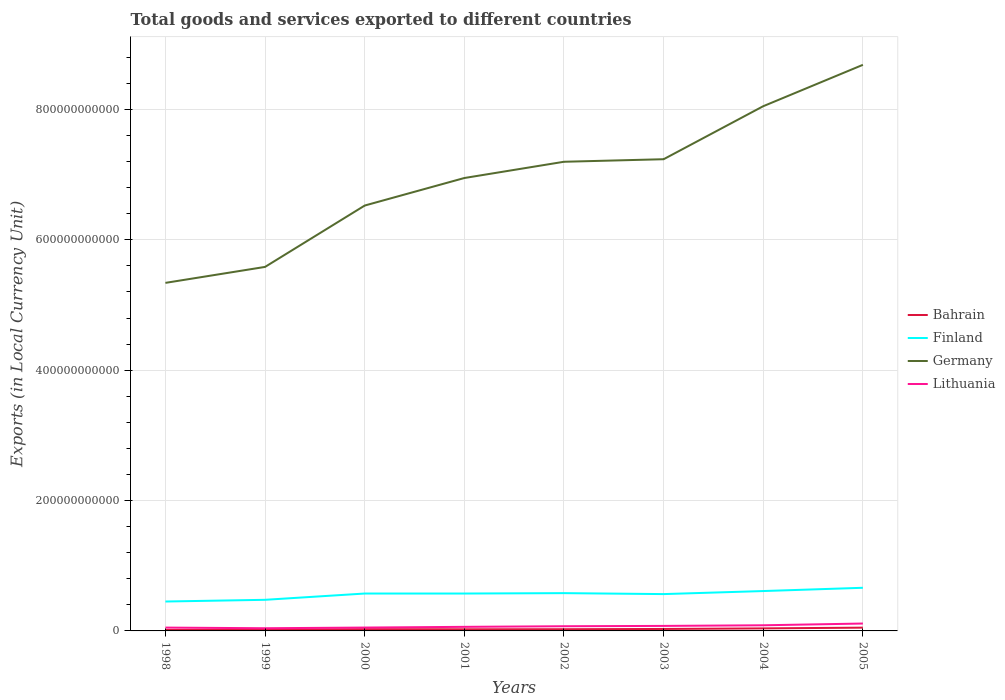How many different coloured lines are there?
Provide a succinct answer. 4. Does the line corresponding to Lithuania intersect with the line corresponding to Finland?
Give a very brief answer. No. Across all years, what is the maximum Amount of goods and services exports in Finland?
Ensure brevity in your answer.  4.51e+1. In which year was the Amount of goods and services exports in Lithuania maximum?
Offer a very short reply. 1999. What is the total Amount of goods and services exports in Finland in the graph?
Keep it short and to the point. -6.12e+08. What is the difference between the highest and the second highest Amount of goods and services exports in Lithuania?
Keep it short and to the point. 7.20e+09. How many years are there in the graph?
Keep it short and to the point. 8. What is the difference between two consecutive major ticks on the Y-axis?
Offer a terse response. 2.00e+11. Does the graph contain any zero values?
Make the answer very short. No. Does the graph contain grids?
Your answer should be compact. Yes. Where does the legend appear in the graph?
Provide a short and direct response. Center right. How many legend labels are there?
Your answer should be compact. 4. How are the legend labels stacked?
Offer a terse response. Vertical. What is the title of the graph?
Offer a terse response. Total goods and services exported to different countries. Does "Switzerland" appear as one of the legend labels in the graph?
Provide a succinct answer. No. What is the label or title of the X-axis?
Provide a succinct answer. Years. What is the label or title of the Y-axis?
Provide a succinct answer. Exports (in Local Currency Unit). What is the Exports (in Local Currency Unit) of Bahrain in 1998?
Give a very brief answer. 1.50e+09. What is the Exports (in Local Currency Unit) in Finland in 1998?
Offer a very short reply. 4.51e+1. What is the Exports (in Local Currency Unit) of Germany in 1998?
Provide a short and direct response. 5.34e+11. What is the Exports (in Local Currency Unit) in Lithuania in 1998?
Offer a very short reply. 5.09e+09. What is the Exports (in Local Currency Unit) in Bahrain in 1999?
Provide a short and direct response. 1.96e+09. What is the Exports (in Local Currency Unit) in Finland in 1999?
Offer a very short reply. 4.77e+1. What is the Exports (in Local Currency Unit) of Germany in 1999?
Provide a succinct answer. 5.58e+11. What is the Exports (in Local Currency Unit) in Lithuania in 1999?
Your answer should be compact. 4.12e+09. What is the Exports (in Local Currency Unit) in Bahrain in 2000?
Your response must be concise. 2.70e+09. What is the Exports (in Local Currency Unit) in Finland in 2000?
Your answer should be very brief. 5.73e+1. What is the Exports (in Local Currency Unit) of Germany in 2000?
Your answer should be very brief. 6.53e+11. What is the Exports (in Local Currency Unit) in Lithuania in 2000?
Your answer should be very brief. 5.15e+09. What is the Exports (in Local Currency Unit) in Bahrain in 2001?
Give a very brief answer. 2.48e+09. What is the Exports (in Local Currency Unit) of Finland in 2001?
Provide a succinct answer. 5.74e+1. What is the Exports (in Local Currency Unit) of Germany in 2001?
Provide a short and direct response. 6.95e+11. What is the Exports (in Local Currency Unit) of Lithuania in 2001?
Offer a terse response. 6.25e+09. What is the Exports (in Local Currency Unit) of Bahrain in 2002?
Keep it short and to the point. 2.62e+09. What is the Exports (in Local Currency Unit) of Finland in 2002?
Offer a terse response. 5.80e+1. What is the Exports (in Local Currency Unit) in Germany in 2002?
Offer a very short reply. 7.20e+11. What is the Exports (in Local Currency Unit) in Lithuania in 2002?
Your response must be concise. 7.20e+09. What is the Exports (in Local Currency Unit) in Bahrain in 2003?
Give a very brief answer. 3.00e+09. What is the Exports (in Local Currency Unit) of Finland in 2003?
Keep it short and to the point. 5.65e+1. What is the Exports (in Local Currency Unit) of Germany in 2003?
Offer a very short reply. 7.24e+11. What is the Exports (in Local Currency Unit) in Lithuania in 2003?
Your response must be concise. 7.70e+09. What is the Exports (in Local Currency Unit) in Bahrain in 2004?
Provide a succinct answer. 3.89e+09. What is the Exports (in Local Currency Unit) of Finland in 2004?
Your answer should be compact. 6.12e+1. What is the Exports (in Local Currency Unit) in Germany in 2004?
Offer a very short reply. 8.05e+11. What is the Exports (in Local Currency Unit) of Lithuania in 2004?
Your response must be concise. 8.64e+09. What is the Exports (in Local Currency Unit) of Bahrain in 2005?
Make the answer very short. 5.04e+09. What is the Exports (in Local Currency Unit) of Finland in 2005?
Offer a terse response. 6.62e+1. What is the Exports (in Local Currency Unit) in Germany in 2005?
Your answer should be very brief. 8.68e+11. What is the Exports (in Local Currency Unit) in Lithuania in 2005?
Provide a short and direct response. 1.13e+1. Across all years, what is the maximum Exports (in Local Currency Unit) of Bahrain?
Your response must be concise. 5.04e+09. Across all years, what is the maximum Exports (in Local Currency Unit) in Finland?
Provide a succinct answer. 6.62e+1. Across all years, what is the maximum Exports (in Local Currency Unit) in Germany?
Make the answer very short. 8.68e+11. Across all years, what is the maximum Exports (in Local Currency Unit) of Lithuania?
Make the answer very short. 1.13e+1. Across all years, what is the minimum Exports (in Local Currency Unit) in Bahrain?
Your response must be concise. 1.50e+09. Across all years, what is the minimum Exports (in Local Currency Unit) in Finland?
Provide a short and direct response. 4.51e+1. Across all years, what is the minimum Exports (in Local Currency Unit) in Germany?
Offer a terse response. 5.34e+11. Across all years, what is the minimum Exports (in Local Currency Unit) of Lithuania?
Your answer should be very brief. 4.12e+09. What is the total Exports (in Local Currency Unit) in Bahrain in the graph?
Your answer should be compact. 2.32e+1. What is the total Exports (in Local Currency Unit) in Finland in the graph?
Make the answer very short. 4.49e+11. What is the total Exports (in Local Currency Unit) in Germany in the graph?
Your answer should be compact. 5.56e+12. What is the total Exports (in Local Currency Unit) in Lithuania in the graph?
Your answer should be compact. 5.55e+1. What is the difference between the Exports (in Local Currency Unit) of Bahrain in 1998 and that in 1999?
Offer a very short reply. -4.61e+08. What is the difference between the Exports (in Local Currency Unit) in Finland in 1998 and that in 1999?
Provide a succinct answer. -2.62e+09. What is the difference between the Exports (in Local Currency Unit) in Germany in 1998 and that in 1999?
Your answer should be compact. -2.45e+1. What is the difference between the Exports (in Local Currency Unit) in Lithuania in 1998 and that in 1999?
Ensure brevity in your answer.  9.74e+08. What is the difference between the Exports (in Local Currency Unit) in Bahrain in 1998 and that in 2000?
Make the answer very short. -1.20e+09. What is the difference between the Exports (in Local Currency Unit) of Finland in 1998 and that in 2000?
Provide a succinct answer. -1.22e+1. What is the difference between the Exports (in Local Currency Unit) of Germany in 1998 and that in 2000?
Offer a terse response. -1.19e+11. What is the difference between the Exports (in Local Currency Unit) of Lithuania in 1998 and that in 2000?
Offer a terse response. -5.80e+07. What is the difference between the Exports (in Local Currency Unit) in Bahrain in 1998 and that in 2001?
Offer a very short reply. -9.82e+08. What is the difference between the Exports (in Local Currency Unit) in Finland in 1998 and that in 2001?
Make the answer very short. -1.23e+1. What is the difference between the Exports (in Local Currency Unit) of Germany in 1998 and that in 2001?
Provide a succinct answer. -1.61e+11. What is the difference between the Exports (in Local Currency Unit) of Lithuania in 1998 and that in 2001?
Offer a very short reply. -1.16e+09. What is the difference between the Exports (in Local Currency Unit) of Bahrain in 1998 and that in 2002?
Provide a short and direct response. -1.11e+09. What is the difference between the Exports (in Local Currency Unit) in Finland in 1998 and that in 2002?
Provide a short and direct response. -1.29e+1. What is the difference between the Exports (in Local Currency Unit) in Germany in 1998 and that in 2002?
Provide a succinct answer. -1.86e+11. What is the difference between the Exports (in Local Currency Unit) of Lithuania in 1998 and that in 2002?
Make the answer very short. -2.10e+09. What is the difference between the Exports (in Local Currency Unit) of Bahrain in 1998 and that in 2003?
Offer a very short reply. -1.50e+09. What is the difference between the Exports (in Local Currency Unit) in Finland in 1998 and that in 2003?
Your response must be concise. -1.14e+1. What is the difference between the Exports (in Local Currency Unit) in Germany in 1998 and that in 2003?
Ensure brevity in your answer.  -1.90e+11. What is the difference between the Exports (in Local Currency Unit) of Lithuania in 1998 and that in 2003?
Provide a succinct answer. -2.60e+09. What is the difference between the Exports (in Local Currency Unit) in Bahrain in 1998 and that in 2004?
Keep it short and to the point. -2.38e+09. What is the difference between the Exports (in Local Currency Unit) of Finland in 1998 and that in 2004?
Offer a terse response. -1.61e+1. What is the difference between the Exports (in Local Currency Unit) of Germany in 1998 and that in 2004?
Provide a short and direct response. -2.71e+11. What is the difference between the Exports (in Local Currency Unit) of Lithuania in 1998 and that in 2004?
Offer a very short reply. -3.55e+09. What is the difference between the Exports (in Local Currency Unit) in Bahrain in 1998 and that in 2005?
Offer a very short reply. -3.54e+09. What is the difference between the Exports (in Local Currency Unit) in Finland in 1998 and that in 2005?
Your answer should be compact. -2.11e+1. What is the difference between the Exports (in Local Currency Unit) of Germany in 1998 and that in 2005?
Provide a succinct answer. -3.34e+11. What is the difference between the Exports (in Local Currency Unit) in Lithuania in 1998 and that in 2005?
Keep it short and to the point. -6.23e+09. What is the difference between the Exports (in Local Currency Unit) of Bahrain in 1999 and that in 2000?
Offer a very short reply. -7.35e+08. What is the difference between the Exports (in Local Currency Unit) of Finland in 1999 and that in 2000?
Give a very brief answer. -9.62e+09. What is the difference between the Exports (in Local Currency Unit) of Germany in 1999 and that in 2000?
Offer a very short reply. -9.41e+1. What is the difference between the Exports (in Local Currency Unit) of Lithuania in 1999 and that in 2000?
Your answer should be compact. -1.03e+09. What is the difference between the Exports (in Local Currency Unit) of Bahrain in 1999 and that in 2001?
Keep it short and to the point. -5.21e+08. What is the difference between the Exports (in Local Currency Unit) of Finland in 1999 and that in 2001?
Provide a short and direct response. -9.63e+09. What is the difference between the Exports (in Local Currency Unit) of Germany in 1999 and that in 2001?
Your response must be concise. -1.36e+11. What is the difference between the Exports (in Local Currency Unit) of Lithuania in 1999 and that in 2001?
Provide a short and direct response. -2.13e+09. What is the difference between the Exports (in Local Currency Unit) of Bahrain in 1999 and that in 2002?
Your answer should be compact. -6.52e+08. What is the difference between the Exports (in Local Currency Unit) of Finland in 1999 and that in 2002?
Your answer should be compact. -1.02e+1. What is the difference between the Exports (in Local Currency Unit) in Germany in 1999 and that in 2002?
Provide a succinct answer. -1.61e+11. What is the difference between the Exports (in Local Currency Unit) in Lithuania in 1999 and that in 2002?
Your answer should be very brief. -3.08e+09. What is the difference between the Exports (in Local Currency Unit) of Bahrain in 1999 and that in 2003?
Provide a short and direct response. -1.04e+09. What is the difference between the Exports (in Local Currency Unit) in Finland in 1999 and that in 2003?
Give a very brief answer. -8.76e+09. What is the difference between the Exports (in Local Currency Unit) in Germany in 1999 and that in 2003?
Give a very brief answer. -1.65e+11. What is the difference between the Exports (in Local Currency Unit) of Lithuania in 1999 and that in 2003?
Give a very brief answer. -3.58e+09. What is the difference between the Exports (in Local Currency Unit) of Bahrain in 1999 and that in 2004?
Keep it short and to the point. -1.92e+09. What is the difference between the Exports (in Local Currency Unit) in Finland in 1999 and that in 2004?
Keep it short and to the point. -1.34e+1. What is the difference between the Exports (in Local Currency Unit) of Germany in 1999 and that in 2004?
Make the answer very short. -2.47e+11. What is the difference between the Exports (in Local Currency Unit) of Lithuania in 1999 and that in 2004?
Give a very brief answer. -4.52e+09. What is the difference between the Exports (in Local Currency Unit) of Bahrain in 1999 and that in 2005?
Keep it short and to the point. -3.07e+09. What is the difference between the Exports (in Local Currency Unit) in Finland in 1999 and that in 2005?
Offer a terse response. -1.84e+1. What is the difference between the Exports (in Local Currency Unit) of Germany in 1999 and that in 2005?
Provide a succinct answer. -3.10e+11. What is the difference between the Exports (in Local Currency Unit) in Lithuania in 1999 and that in 2005?
Your response must be concise. -7.20e+09. What is the difference between the Exports (in Local Currency Unit) in Bahrain in 2000 and that in 2001?
Offer a very short reply. 2.14e+08. What is the difference between the Exports (in Local Currency Unit) of Finland in 2000 and that in 2001?
Ensure brevity in your answer.  -1.20e+07. What is the difference between the Exports (in Local Currency Unit) of Germany in 2000 and that in 2001?
Offer a very short reply. -4.22e+1. What is the difference between the Exports (in Local Currency Unit) of Lithuania in 2000 and that in 2001?
Provide a short and direct response. -1.10e+09. What is the difference between the Exports (in Local Currency Unit) of Bahrain in 2000 and that in 2002?
Your answer should be very brief. 8.27e+07. What is the difference between the Exports (in Local Currency Unit) in Finland in 2000 and that in 2002?
Your response must be concise. -6.12e+08. What is the difference between the Exports (in Local Currency Unit) of Germany in 2000 and that in 2002?
Make the answer very short. -6.72e+1. What is the difference between the Exports (in Local Currency Unit) in Lithuania in 2000 and that in 2002?
Provide a succinct answer. -2.04e+09. What is the difference between the Exports (in Local Currency Unit) in Bahrain in 2000 and that in 2003?
Your answer should be very brief. -3.03e+08. What is the difference between the Exports (in Local Currency Unit) of Finland in 2000 and that in 2003?
Your answer should be compact. 8.64e+08. What is the difference between the Exports (in Local Currency Unit) of Germany in 2000 and that in 2003?
Provide a succinct answer. -7.11e+1. What is the difference between the Exports (in Local Currency Unit) of Lithuania in 2000 and that in 2003?
Ensure brevity in your answer.  -2.54e+09. What is the difference between the Exports (in Local Currency Unit) in Bahrain in 2000 and that in 2004?
Offer a terse response. -1.19e+09. What is the difference between the Exports (in Local Currency Unit) of Finland in 2000 and that in 2004?
Your answer should be very brief. -3.81e+09. What is the difference between the Exports (in Local Currency Unit) in Germany in 2000 and that in 2004?
Give a very brief answer. -1.52e+11. What is the difference between the Exports (in Local Currency Unit) in Lithuania in 2000 and that in 2004?
Your answer should be very brief. -3.49e+09. What is the difference between the Exports (in Local Currency Unit) of Bahrain in 2000 and that in 2005?
Your answer should be compact. -2.34e+09. What is the difference between the Exports (in Local Currency Unit) in Finland in 2000 and that in 2005?
Offer a terse response. -8.83e+09. What is the difference between the Exports (in Local Currency Unit) of Germany in 2000 and that in 2005?
Ensure brevity in your answer.  -2.16e+11. What is the difference between the Exports (in Local Currency Unit) of Lithuania in 2000 and that in 2005?
Keep it short and to the point. -6.17e+09. What is the difference between the Exports (in Local Currency Unit) of Bahrain in 2001 and that in 2002?
Provide a short and direct response. -1.31e+08. What is the difference between the Exports (in Local Currency Unit) of Finland in 2001 and that in 2002?
Keep it short and to the point. -6.00e+08. What is the difference between the Exports (in Local Currency Unit) in Germany in 2001 and that in 2002?
Give a very brief answer. -2.49e+1. What is the difference between the Exports (in Local Currency Unit) in Lithuania in 2001 and that in 2002?
Offer a very short reply. -9.45e+08. What is the difference between the Exports (in Local Currency Unit) in Bahrain in 2001 and that in 2003?
Make the answer very short. -5.16e+08. What is the difference between the Exports (in Local Currency Unit) of Finland in 2001 and that in 2003?
Give a very brief answer. 8.76e+08. What is the difference between the Exports (in Local Currency Unit) of Germany in 2001 and that in 2003?
Your response must be concise. -2.88e+1. What is the difference between the Exports (in Local Currency Unit) in Lithuania in 2001 and that in 2003?
Offer a very short reply. -1.44e+09. What is the difference between the Exports (in Local Currency Unit) in Bahrain in 2001 and that in 2004?
Your answer should be very brief. -1.40e+09. What is the difference between the Exports (in Local Currency Unit) in Finland in 2001 and that in 2004?
Provide a short and direct response. -3.80e+09. What is the difference between the Exports (in Local Currency Unit) of Germany in 2001 and that in 2004?
Your answer should be compact. -1.10e+11. What is the difference between the Exports (in Local Currency Unit) in Lithuania in 2001 and that in 2004?
Your answer should be compact. -2.39e+09. What is the difference between the Exports (in Local Currency Unit) in Bahrain in 2001 and that in 2005?
Make the answer very short. -2.55e+09. What is the difference between the Exports (in Local Currency Unit) in Finland in 2001 and that in 2005?
Your response must be concise. -8.82e+09. What is the difference between the Exports (in Local Currency Unit) in Germany in 2001 and that in 2005?
Provide a succinct answer. -1.74e+11. What is the difference between the Exports (in Local Currency Unit) in Lithuania in 2001 and that in 2005?
Offer a terse response. -5.07e+09. What is the difference between the Exports (in Local Currency Unit) in Bahrain in 2002 and that in 2003?
Your answer should be compact. -3.85e+08. What is the difference between the Exports (in Local Currency Unit) in Finland in 2002 and that in 2003?
Ensure brevity in your answer.  1.48e+09. What is the difference between the Exports (in Local Currency Unit) of Germany in 2002 and that in 2003?
Offer a terse response. -3.90e+09. What is the difference between the Exports (in Local Currency Unit) of Lithuania in 2002 and that in 2003?
Your answer should be compact. -4.99e+08. What is the difference between the Exports (in Local Currency Unit) in Bahrain in 2002 and that in 2004?
Your response must be concise. -1.27e+09. What is the difference between the Exports (in Local Currency Unit) of Finland in 2002 and that in 2004?
Offer a terse response. -3.20e+09. What is the difference between the Exports (in Local Currency Unit) in Germany in 2002 and that in 2004?
Keep it short and to the point. -8.52e+1. What is the difference between the Exports (in Local Currency Unit) of Lithuania in 2002 and that in 2004?
Keep it short and to the point. -1.45e+09. What is the difference between the Exports (in Local Currency Unit) of Bahrain in 2002 and that in 2005?
Keep it short and to the point. -2.42e+09. What is the difference between the Exports (in Local Currency Unit) in Finland in 2002 and that in 2005?
Your response must be concise. -8.22e+09. What is the difference between the Exports (in Local Currency Unit) of Germany in 2002 and that in 2005?
Provide a succinct answer. -1.49e+11. What is the difference between the Exports (in Local Currency Unit) in Lithuania in 2002 and that in 2005?
Offer a very short reply. -4.13e+09. What is the difference between the Exports (in Local Currency Unit) of Bahrain in 2003 and that in 2004?
Provide a succinct answer. -8.86e+08. What is the difference between the Exports (in Local Currency Unit) in Finland in 2003 and that in 2004?
Ensure brevity in your answer.  -4.67e+09. What is the difference between the Exports (in Local Currency Unit) in Germany in 2003 and that in 2004?
Provide a short and direct response. -8.13e+1. What is the difference between the Exports (in Local Currency Unit) of Lithuania in 2003 and that in 2004?
Ensure brevity in your answer.  -9.48e+08. What is the difference between the Exports (in Local Currency Unit) of Bahrain in 2003 and that in 2005?
Make the answer very short. -2.04e+09. What is the difference between the Exports (in Local Currency Unit) in Finland in 2003 and that in 2005?
Ensure brevity in your answer.  -9.69e+09. What is the difference between the Exports (in Local Currency Unit) of Germany in 2003 and that in 2005?
Give a very brief answer. -1.45e+11. What is the difference between the Exports (in Local Currency Unit) in Lithuania in 2003 and that in 2005?
Offer a very short reply. -3.63e+09. What is the difference between the Exports (in Local Currency Unit) of Bahrain in 2004 and that in 2005?
Make the answer very short. -1.15e+09. What is the difference between the Exports (in Local Currency Unit) in Finland in 2004 and that in 2005?
Your response must be concise. -5.02e+09. What is the difference between the Exports (in Local Currency Unit) in Germany in 2004 and that in 2005?
Provide a short and direct response. -6.35e+1. What is the difference between the Exports (in Local Currency Unit) of Lithuania in 2004 and that in 2005?
Give a very brief answer. -2.68e+09. What is the difference between the Exports (in Local Currency Unit) in Bahrain in 1998 and the Exports (in Local Currency Unit) in Finland in 1999?
Offer a very short reply. -4.62e+1. What is the difference between the Exports (in Local Currency Unit) of Bahrain in 1998 and the Exports (in Local Currency Unit) of Germany in 1999?
Your answer should be very brief. -5.57e+11. What is the difference between the Exports (in Local Currency Unit) in Bahrain in 1998 and the Exports (in Local Currency Unit) in Lithuania in 1999?
Provide a short and direct response. -2.62e+09. What is the difference between the Exports (in Local Currency Unit) in Finland in 1998 and the Exports (in Local Currency Unit) in Germany in 1999?
Your answer should be compact. -5.13e+11. What is the difference between the Exports (in Local Currency Unit) in Finland in 1998 and the Exports (in Local Currency Unit) in Lithuania in 1999?
Make the answer very short. 4.10e+1. What is the difference between the Exports (in Local Currency Unit) in Germany in 1998 and the Exports (in Local Currency Unit) in Lithuania in 1999?
Your response must be concise. 5.30e+11. What is the difference between the Exports (in Local Currency Unit) of Bahrain in 1998 and the Exports (in Local Currency Unit) of Finland in 2000?
Offer a terse response. -5.58e+1. What is the difference between the Exports (in Local Currency Unit) of Bahrain in 1998 and the Exports (in Local Currency Unit) of Germany in 2000?
Give a very brief answer. -6.51e+11. What is the difference between the Exports (in Local Currency Unit) of Bahrain in 1998 and the Exports (in Local Currency Unit) of Lithuania in 2000?
Offer a terse response. -3.65e+09. What is the difference between the Exports (in Local Currency Unit) of Finland in 1998 and the Exports (in Local Currency Unit) of Germany in 2000?
Provide a succinct answer. -6.07e+11. What is the difference between the Exports (in Local Currency Unit) of Finland in 1998 and the Exports (in Local Currency Unit) of Lithuania in 2000?
Ensure brevity in your answer.  4.00e+1. What is the difference between the Exports (in Local Currency Unit) of Germany in 1998 and the Exports (in Local Currency Unit) of Lithuania in 2000?
Provide a succinct answer. 5.29e+11. What is the difference between the Exports (in Local Currency Unit) of Bahrain in 1998 and the Exports (in Local Currency Unit) of Finland in 2001?
Keep it short and to the point. -5.59e+1. What is the difference between the Exports (in Local Currency Unit) of Bahrain in 1998 and the Exports (in Local Currency Unit) of Germany in 2001?
Your answer should be very brief. -6.93e+11. What is the difference between the Exports (in Local Currency Unit) in Bahrain in 1998 and the Exports (in Local Currency Unit) in Lithuania in 2001?
Offer a terse response. -4.75e+09. What is the difference between the Exports (in Local Currency Unit) in Finland in 1998 and the Exports (in Local Currency Unit) in Germany in 2001?
Your answer should be very brief. -6.50e+11. What is the difference between the Exports (in Local Currency Unit) in Finland in 1998 and the Exports (in Local Currency Unit) in Lithuania in 2001?
Your answer should be compact. 3.89e+1. What is the difference between the Exports (in Local Currency Unit) of Germany in 1998 and the Exports (in Local Currency Unit) of Lithuania in 2001?
Offer a very short reply. 5.28e+11. What is the difference between the Exports (in Local Currency Unit) of Bahrain in 1998 and the Exports (in Local Currency Unit) of Finland in 2002?
Give a very brief answer. -5.65e+1. What is the difference between the Exports (in Local Currency Unit) in Bahrain in 1998 and the Exports (in Local Currency Unit) in Germany in 2002?
Ensure brevity in your answer.  -7.18e+11. What is the difference between the Exports (in Local Currency Unit) in Bahrain in 1998 and the Exports (in Local Currency Unit) in Lithuania in 2002?
Provide a short and direct response. -5.69e+09. What is the difference between the Exports (in Local Currency Unit) in Finland in 1998 and the Exports (in Local Currency Unit) in Germany in 2002?
Ensure brevity in your answer.  -6.75e+11. What is the difference between the Exports (in Local Currency Unit) of Finland in 1998 and the Exports (in Local Currency Unit) of Lithuania in 2002?
Your answer should be very brief. 3.79e+1. What is the difference between the Exports (in Local Currency Unit) of Germany in 1998 and the Exports (in Local Currency Unit) of Lithuania in 2002?
Provide a short and direct response. 5.27e+11. What is the difference between the Exports (in Local Currency Unit) of Bahrain in 1998 and the Exports (in Local Currency Unit) of Finland in 2003?
Your answer should be compact. -5.50e+1. What is the difference between the Exports (in Local Currency Unit) in Bahrain in 1998 and the Exports (in Local Currency Unit) in Germany in 2003?
Offer a terse response. -7.22e+11. What is the difference between the Exports (in Local Currency Unit) in Bahrain in 1998 and the Exports (in Local Currency Unit) in Lithuania in 2003?
Make the answer very short. -6.19e+09. What is the difference between the Exports (in Local Currency Unit) in Finland in 1998 and the Exports (in Local Currency Unit) in Germany in 2003?
Your answer should be compact. -6.78e+11. What is the difference between the Exports (in Local Currency Unit) of Finland in 1998 and the Exports (in Local Currency Unit) of Lithuania in 2003?
Provide a short and direct response. 3.74e+1. What is the difference between the Exports (in Local Currency Unit) in Germany in 1998 and the Exports (in Local Currency Unit) in Lithuania in 2003?
Make the answer very short. 5.26e+11. What is the difference between the Exports (in Local Currency Unit) of Bahrain in 1998 and the Exports (in Local Currency Unit) of Finland in 2004?
Give a very brief answer. -5.97e+1. What is the difference between the Exports (in Local Currency Unit) in Bahrain in 1998 and the Exports (in Local Currency Unit) in Germany in 2004?
Keep it short and to the point. -8.03e+11. What is the difference between the Exports (in Local Currency Unit) in Bahrain in 1998 and the Exports (in Local Currency Unit) in Lithuania in 2004?
Give a very brief answer. -7.14e+09. What is the difference between the Exports (in Local Currency Unit) in Finland in 1998 and the Exports (in Local Currency Unit) in Germany in 2004?
Your answer should be very brief. -7.60e+11. What is the difference between the Exports (in Local Currency Unit) of Finland in 1998 and the Exports (in Local Currency Unit) of Lithuania in 2004?
Keep it short and to the point. 3.65e+1. What is the difference between the Exports (in Local Currency Unit) in Germany in 1998 and the Exports (in Local Currency Unit) in Lithuania in 2004?
Offer a very short reply. 5.25e+11. What is the difference between the Exports (in Local Currency Unit) of Bahrain in 1998 and the Exports (in Local Currency Unit) of Finland in 2005?
Keep it short and to the point. -6.47e+1. What is the difference between the Exports (in Local Currency Unit) in Bahrain in 1998 and the Exports (in Local Currency Unit) in Germany in 2005?
Offer a terse response. -8.67e+11. What is the difference between the Exports (in Local Currency Unit) of Bahrain in 1998 and the Exports (in Local Currency Unit) of Lithuania in 2005?
Keep it short and to the point. -9.82e+09. What is the difference between the Exports (in Local Currency Unit) in Finland in 1998 and the Exports (in Local Currency Unit) in Germany in 2005?
Keep it short and to the point. -8.23e+11. What is the difference between the Exports (in Local Currency Unit) in Finland in 1998 and the Exports (in Local Currency Unit) in Lithuania in 2005?
Your answer should be compact. 3.38e+1. What is the difference between the Exports (in Local Currency Unit) in Germany in 1998 and the Exports (in Local Currency Unit) in Lithuania in 2005?
Offer a very short reply. 5.23e+11. What is the difference between the Exports (in Local Currency Unit) in Bahrain in 1999 and the Exports (in Local Currency Unit) in Finland in 2000?
Provide a succinct answer. -5.54e+1. What is the difference between the Exports (in Local Currency Unit) of Bahrain in 1999 and the Exports (in Local Currency Unit) of Germany in 2000?
Provide a succinct answer. -6.51e+11. What is the difference between the Exports (in Local Currency Unit) in Bahrain in 1999 and the Exports (in Local Currency Unit) in Lithuania in 2000?
Your answer should be very brief. -3.19e+09. What is the difference between the Exports (in Local Currency Unit) in Finland in 1999 and the Exports (in Local Currency Unit) in Germany in 2000?
Keep it short and to the point. -6.05e+11. What is the difference between the Exports (in Local Currency Unit) of Finland in 1999 and the Exports (in Local Currency Unit) of Lithuania in 2000?
Make the answer very short. 4.26e+1. What is the difference between the Exports (in Local Currency Unit) in Germany in 1999 and the Exports (in Local Currency Unit) in Lithuania in 2000?
Your response must be concise. 5.53e+11. What is the difference between the Exports (in Local Currency Unit) in Bahrain in 1999 and the Exports (in Local Currency Unit) in Finland in 2001?
Give a very brief answer. -5.54e+1. What is the difference between the Exports (in Local Currency Unit) of Bahrain in 1999 and the Exports (in Local Currency Unit) of Germany in 2001?
Your response must be concise. -6.93e+11. What is the difference between the Exports (in Local Currency Unit) of Bahrain in 1999 and the Exports (in Local Currency Unit) of Lithuania in 2001?
Ensure brevity in your answer.  -4.29e+09. What is the difference between the Exports (in Local Currency Unit) of Finland in 1999 and the Exports (in Local Currency Unit) of Germany in 2001?
Offer a terse response. -6.47e+11. What is the difference between the Exports (in Local Currency Unit) of Finland in 1999 and the Exports (in Local Currency Unit) of Lithuania in 2001?
Your response must be concise. 4.15e+1. What is the difference between the Exports (in Local Currency Unit) of Germany in 1999 and the Exports (in Local Currency Unit) of Lithuania in 2001?
Offer a very short reply. 5.52e+11. What is the difference between the Exports (in Local Currency Unit) in Bahrain in 1999 and the Exports (in Local Currency Unit) in Finland in 2002?
Your answer should be very brief. -5.60e+1. What is the difference between the Exports (in Local Currency Unit) in Bahrain in 1999 and the Exports (in Local Currency Unit) in Germany in 2002?
Make the answer very short. -7.18e+11. What is the difference between the Exports (in Local Currency Unit) in Bahrain in 1999 and the Exports (in Local Currency Unit) in Lithuania in 2002?
Your answer should be compact. -5.23e+09. What is the difference between the Exports (in Local Currency Unit) in Finland in 1999 and the Exports (in Local Currency Unit) in Germany in 2002?
Offer a terse response. -6.72e+11. What is the difference between the Exports (in Local Currency Unit) of Finland in 1999 and the Exports (in Local Currency Unit) of Lithuania in 2002?
Your answer should be very brief. 4.05e+1. What is the difference between the Exports (in Local Currency Unit) of Germany in 1999 and the Exports (in Local Currency Unit) of Lithuania in 2002?
Provide a succinct answer. 5.51e+11. What is the difference between the Exports (in Local Currency Unit) of Bahrain in 1999 and the Exports (in Local Currency Unit) of Finland in 2003?
Your response must be concise. -5.45e+1. What is the difference between the Exports (in Local Currency Unit) in Bahrain in 1999 and the Exports (in Local Currency Unit) in Germany in 2003?
Give a very brief answer. -7.22e+11. What is the difference between the Exports (in Local Currency Unit) of Bahrain in 1999 and the Exports (in Local Currency Unit) of Lithuania in 2003?
Keep it short and to the point. -5.73e+09. What is the difference between the Exports (in Local Currency Unit) of Finland in 1999 and the Exports (in Local Currency Unit) of Germany in 2003?
Ensure brevity in your answer.  -6.76e+11. What is the difference between the Exports (in Local Currency Unit) in Finland in 1999 and the Exports (in Local Currency Unit) in Lithuania in 2003?
Your response must be concise. 4.00e+1. What is the difference between the Exports (in Local Currency Unit) of Germany in 1999 and the Exports (in Local Currency Unit) of Lithuania in 2003?
Offer a terse response. 5.51e+11. What is the difference between the Exports (in Local Currency Unit) of Bahrain in 1999 and the Exports (in Local Currency Unit) of Finland in 2004?
Your response must be concise. -5.92e+1. What is the difference between the Exports (in Local Currency Unit) in Bahrain in 1999 and the Exports (in Local Currency Unit) in Germany in 2004?
Your answer should be very brief. -8.03e+11. What is the difference between the Exports (in Local Currency Unit) of Bahrain in 1999 and the Exports (in Local Currency Unit) of Lithuania in 2004?
Your answer should be compact. -6.68e+09. What is the difference between the Exports (in Local Currency Unit) of Finland in 1999 and the Exports (in Local Currency Unit) of Germany in 2004?
Provide a succinct answer. -7.57e+11. What is the difference between the Exports (in Local Currency Unit) in Finland in 1999 and the Exports (in Local Currency Unit) in Lithuania in 2004?
Make the answer very short. 3.91e+1. What is the difference between the Exports (in Local Currency Unit) of Germany in 1999 and the Exports (in Local Currency Unit) of Lithuania in 2004?
Keep it short and to the point. 5.50e+11. What is the difference between the Exports (in Local Currency Unit) in Bahrain in 1999 and the Exports (in Local Currency Unit) in Finland in 2005?
Provide a succinct answer. -6.42e+1. What is the difference between the Exports (in Local Currency Unit) of Bahrain in 1999 and the Exports (in Local Currency Unit) of Germany in 2005?
Provide a short and direct response. -8.66e+11. What is the difference between the Exports (in Local Currency Unit) of Bahrain in 1999 and the Exports (in Local Currency Unit) of Lithuania in 2005?
Ensure brevity in your answer.  -9.36e+09. What is the difference between the Exports (in Local Currency Unit) of Finland in 1999 and the Exports (in Local Currency Unit) of Germany in 2005?
Your response must be concise. -8.21e+11. What is the difference between the Exports (in Local Currency Unit) of Finland in 1999 and the Exports (in Local Currency Unit) of Lithuania in 2005?
Make the answer very short. 3.64e+1. What is the difference between the Exports (in Local Currency Unit) in Germany in 1999 and the Exports (in Local Currency Unit) in Lithuania in 2005?
Your answer should be very brief. 5.47e+11. What is the difference between the Exports (in Local Currency Unit) of Bahrain in 2000 and the Exports (in Local Currency Unit) of Finland in 2001?
Provide a short and direct response. -5.47e+1. What is the difference between the Exports (in Local Currency Unit) of Bahrain in 2000 and the Exports (in Local Currency Unit) of Germany in 2001?
Make the answer very short. -6.92e+11. What is the difference between the Exports (in Local Currency Unit) of Bahrain in 2000 and the Exports (in Local Currency Unit) of Lithuania in 2001?
Keep it short and to the point. -3.55e+09. What is the difference between the Exports (in Local Currency Unit) of Finland in 2000 and the Exports (in Local Currency Unit) of Germany in 2001?
Provide a short and direct response. -6.37e+11. What is the difference between the Exports (in Local Currency Unit) of Finland in 2000 and the Exports (in Local Currency Unit) of Lithuania in 2001?
Your answer should be compact. 5.11e+1. What is the difference between the Exports (in Local Currency Unit) in Germany in 2000 and the Exports (in Local Currency Unit) in Lithuania in 2001?
Offer a very short reply. 6.46e+11. What is the difference between the Exports (in Local Currency Unit) of Bahrain in 2000 and the Exports (in Local Currency Unit) of Finland in 2002?
Keep it short and to the point. -5.53e+1. What is the difference between the Exports (in Local Currency Unit) of Bahrain in 2000 and the Exports (in Local Currency Unit) of Germany in 2002?
Give a very brief answer. -7.17e+11. What is the difference between the Exports (in Local Currency Unit) in Bahrain in 2000 and the Exports (in Local Currency Unit) in Lithuania in 2002?
Provide a short and direct response. -4.50e+09. What is the difference between the Exports (in Local Currency Unit) of Finland in 2000 and the Exports (in Local Currency Unit) of Germany in 2002?
Your response must be concise. -6.62e+11. What is the difference between the Exports (in Local Currency Unit) in Finland in 2000 and the Exports (in Local Currency Unit) in Lithuania in 2002?
Keep it short and to the point. 5.02e+1. What is the difference between the Exports (in Local Currency Unit) of Germany in 2000 and the Exports (in Local Currency Unit) of Lithuania in 2002?
Your response must be concise. 6.45e+11. What is the difference between the Exports (in Local Currency Unit) of Bahrain in 2000 and the Exports (in Local Currency Unit) of Finland in 2003?
Offer a very short reply. -5.38e+1. What is the difference between the Exports (in Local Currency Unit) in Bahrain in 2000 and the Exports (in Local Currency Unit) in Germany in 2003?
Your response must be concise. -7.21e+11. What is the difference between the Exports (in Local Currency Unit) of Bahrain in 2000 and the Exports (in Local Currency Unit) of Lithuania in 2003?
Make the answer very short. -5.00e+09. What is the difference between the Exports (in Local Currency Unit) in Finland in 2000 and the Exports (in Local Currency Unit) in Germany in 2003?
Provide a succinct answer. -6.66e+11. What is the difference between the Exports (in Local Currency Unit) of Finland in 2000 and the Exports (in Local Currency Unit) of Lithuania in 2003?
Your answer should be compact. 4.97e+1. What is the difference between the Exports (in Local Currency Unit) of Germany in 2000 and the Exports (in Local Currency Unit) of Lithuania in 2003?
Offer a terse response. 6.45e+11. What is the difference between the Exports (in Local Currency Unit) in Bahrain in 2000 and the Exports (in Local Currency Unit) in Finland in 2004?
Provide a short and direct response. -5.85e+1. What is the difference between the Exports (in Local Currency Unit) in Bahrain in 2000 and the Exports (in Local Currency Unit) in Germany in 2004?
Keep it short and to the point. -8.02e+11. What is the difference between the Exports (in Local Currency Unit) in Bahrain in 2000 and the Exports (in Local Currency Unit) in Lithuania in 2004?
Provide a short and direct response. -5.95e+09. What is the difference between the Exports (in Local Currency Unit) of Finland in 2000 and the Exports (in Local Currency Unit) of Germany in 2004?
Give a very brief answer. -7.48e+11. What is the difference between the Exports (in Local Currency Unit) of Finland in 2000 and the Exports (in Local Currency Unit) of Lithuania in 2004?
Make the answer very short. 4.87e+1. What is the difference between the Exports (in Local Currency Unit) in Germany in 2000 and the Exports (in Local Currency Unit) in Lithuania in 2004?
Provide a short and direct response. 6.44e+11. What is the difference between the Exports (in Local Currency Unit) of Bahrain in 2000 and the Exports (in Local Currency Unit) of Finland in 2005?
Make the answer very short. -6.35e+1. What is the difference between the Exports (in Local Currency Unit) of Bahrain in 2000 and the Exports (in Local Currency Unit) of Germany in 2005?
Ensure brevity in your answer.  -8.66e+11. What is the difference between the Exports (in Local Currency Unit) in Bahrain in 2000 and the Exports (in Local Currency Unit) in Lithuania in 2005?
Keep it short and to the point. -8.63e+09. What is the difference between the Exports (in Local Currency Unit) of Finland in 2000 and the Exports (in Local Currency Unit) of Germany in 2005?
Your answer should be compact. -8.11e+11. What is the difference between the Exports (in Local Currency Unit) in Finland in 2000 and the Exports (in Local Currency Unit) in Lithuania in 2005?
Ensure brevity in your answer.  4.60e+1. What is the difference between the Exports (in Local Currency Unit) of Germany in 2000 and the Exports (in Local Currency Unit) of Lithuania in 2005?
Your response must be concise. 6.41e+11. What is the difference between the Exports (in Local Currency Unit) of Bahrain in 2001 and the Exports (in Local Currency Unit) of Finland in 2002?
Give a very brief answer. -5.55e+1. What is the difference between the Exports (in Local Currency Unit) in Bahrain in 2001 and the Exports (in Local Currency Unit) in Germany in 2002?
Give a very brief answer. -7.17e+11. What is the difference between the Exports (in Local Currency Unit) in Bahrain in 2001 and the Exports (in Local Currency Unit) in Lithuania in 2002?
Offer a terse response. -4.71e+09. What is the difference between the Exports (in Local Currency Unit) in Finland in 2001 and the Exports (in Local Currency Unit) in Germany in 2002?
Offer a very short reply. -6.62e+11. What is the difference between the Exports (in Local Currency Unit) of Finland in 2001 and the Exports (in Local Currency Unit) of Lithuania in 2002?
Provide a short and direct response. 5.02e+1. What is the difference between the Exports (in Local Currency Unit) of Germany in 2001 and the Exports (in Local Currency Unit) of Lithuania in 2002?
Make the answer very short. 6.88e+11. What is the difference between the Exports (in Local Currency Unit) in Bahrain in 2001 and the Exports (in Local Currency Unit) in Finland in 2003?
Offer a very short reply. -5.40e+1. What is the difference between the Exports (in Local Currency Unit) in Bahrain in 2001 and the Exports (in Local Currency Unit) in Germany in 2003?
Provide a succinct answer. -7.21e+11. What is the difference between the Exports (in Local Currency Unit) of Bahrain in 2001 and the Exports (in Local Currency Unit) of Lithuania in 2003?
Provide a succinct answer. -5.21e+09. What is the difference between the Exports (in Local Currency Unit) of Finland in 2001 and the Exports (in Local Currency Unit) of Germany in 2003?
Your response must be concise. -6.66e+11. What is the difference between the Exports (in Local Currency Unit) of Finland in 2001 and the Exports (in Local Currency Unit) of Lithuania in 2003?
Ensure brevity in your answer.  4.97e+1. What is the difference between the Exports (in Local Currency Unit) of Germany in 2001 and the Exports (in Local Currency Unit) of Lithuania in 2003?
Make the answer very short. 6.87e+11. What is the difference between the Exports (in Local Currency Unit) in Bahrain in 2001 and the Exports (in Local Currency Unit) in Finland in 2004?
Your response must be concise. -5.87e+1. What is the difference between the Exports (in Local Currency Unit) of Bahrain in 2001 and the Exports (in Local Currency Unit) of Germany in 2004?
Keep it short and to the point. -8.02e+11. What is the difference between the Exports (in Local Currency Unit) in Bahrain in 2001 and the Exports (in Local Currency Unit) in Lithuania in 2004?
Keep it short and to the point. -6.16e+09. What is the difference between the Exports (in Local Currency Unit) in Finland in 2001 and the Exports (in Local Currency Unit) in Germany in 2004?
Provide a short and direct response. -7.48e+11. What is the difference between the Exports (in Local Currency Unit) of Finland in 2001 and the Exports (in Local Currency Unit) of Lithuania in 2004?
Provide a succinct answer. 4.87e+1. What is the difference between the Exports (in Local Currency Unit) of Germany in 2001 and the Exports (in Local Currency Unit) of Lithuania in 2004?
Offer a very short reply. 6.86e+11. What is the difference between the Exports (in Local Currency Unit) in Bahrain in 2001 and the Exports (in Local Currency Unit) in Finland in 2005?
Your answer should be compact. -6.37e+1. What is the difference between the Exports (in Local Currency Unit) in Bahrain in 2001 and the Exports (in Local Currency Unit) in Germany in 2005?
Your answer should be very brief. -8.66e+11. What is the difference between the Exports (in Local Currency Unit) in Bahrain in 2001 and the Exports (in Local Currency Unit) in Lithuania in 2005?
Make the answer very short. -8.84e+09. What is the difference between the Exports (in Local Currency Unit) of Finland in 2001 and the Exports (in Local Currency Unit) of Germany in 2005?
Ensure brevity in your answer.  -8.11e+11. What is the difference between the Exports (in Local Currency Unit) in Finland in 2001 and the Exports (in Local Currency Unit) in Lithuania in 2005?
Your answer should be very brief. 4.60e+1. What is the difference between the Exports (in Local Currency Unit) in Germany in 2001 and the Exports (in Local Currency Unit) in Lithuania in 2005?
Your answer should be compact. 6.83e+11. What is the difference between the Exports (in Local Currency Unit) of Bahrain in 2002 and the Exports (in Local Currency Unit) of Finland in 2003?
Your answer should be compact. -5.39e+1. What is the difference between the Exports (in Local Currency Unit) of Bahrain in 2002 and the Exports (in Local Currency Unit) of Germany in 2003?
Give a very brief answer. -7.21e+11. What is the difference between the Exports (in Local Currency Unit) of Bahrain in 2002 and the Exports (in Local Currency Unit) of Lithuania in 2003?
Make the answer very short. -5.08e+09. What is the difference between the Exports (in Local Currency Unit) of Finland in 2002 and the Exports (in Local Currency Unit) of Germany in 2003?
Ensure brevity in your answer.  -6.66e+11. What is the difference between the Exports (in Local Currency Unit) of Finland in 2002 and the Exports (in Local Currency Unit) of Lithuania in 2003?
Provide a succinct answer. 5.03e+1. What is the difference between the Exports (in Local Currency Unit) of Germany in 2002 and the Exports (in Local Currency Unit) of Lithuania in 2003?
Keep it short and to the point. 7.12e+11. What is the difference between the Exports (in Local Currency Unit) of Bahrain in 2002 and the Exports (in Local Currency Unit) of Finland in 2004?
Your answer should be very brief. -5.85e+1. What is the difference between the Exports (in Local Currency Unit) in Bahrain in 2002 and the Exports (in Local Currency Unit) in Germany in 2004?
Provide a succinct answer. -8.02e+11. What is the difference between the Exports (in Local Currency Unit) in Bahrain in 2002 and the Exports (in Local Currency Unit) in Lithuania in 2004?
Give a very brief answer. -6.03e+09. What is the difference between the Exports (in Local Currency Unit) of Finland in 2002 and the Exports (in Local Currency Unit) of Germany in 2004?
Provide a short and direct response. -7.47e+11. What is the difference between the Exports (in Local Currency Unit) of Finland in 2002 and the Exports (in Local Currency Unit) of Lithuania in 2004?
Offer a terse response. 4.93e+1. What is the difference between the Exports (in Local Currency Unit) of Germany in 2002 and the Exports (in Local Currency Unit) of Lithuania in 2004?
Make the answer very short. 7.11e+11. What is the difference between the Exports (in Local Currency Unit) of Bahrain in 2002 and the Exports (in Local Currency Unit) of Finland in 2005?
Your answer should be very brief. -6.36e+1. What is the difference between the Exports (in Local Currency Unit) of Bahrain in 2002 and the Exports (in Local Currency Unit) of Germany in 2005?
Your answer should be very brief. -8.66e+11. What is the difference between the Exports (in Local Currency Unit) of Bahrain in 2002 and the Exports (in Local Currency Unit) of Lithuania in 2005?
Provide a short and direct response. -8.71e+09. What is the difference between the Exports (in Local Currency Unit) in Finland in 2002 and the Exports (in Local Currency Unit) in Germany in 2005?
Make the answer very short. -8.10e+11. What is the difference between the Exports (in Local Currency Unit) of Finland in 2002 and the Exports (in Local Currency Unit) of Lithuania in 2005?
Your answer should be very brief. 4.66e+1. What is the difference between the Exports (in Local Currency Unit) in Germany in 2002 and the Exports (in Local Currency Unit) in Lithuania in 2005?
Give a very brief answer. 7.08e+11. What is the difference between the Exports (in Local Currency Unit) of Bahrain in 2003 and the Exports (in Local Currency Unit) of Finland in 2004?
Ensure brevity in your answer.  -5.82e+1. What is the difference between the Exports (in Local Currency Unit) of Bahrain in 2003 and the Exports (in Local Currency Unit) of Germany in 2004?
Your answer should be compact. -8.02e+11. What is the difference between the Exports (in Local Currency Unit) in Bahrain in 2003 and the Exports (in Local Currency Unit) in Lithuania in 2004?
Keep it short and to the point. -5.64e+09. What is the difference between the Exports (in Local Currency Unit) of Finland in 2003 and the Exports (in Local Currency Unit) of Germany in 2004?
Provide a short and direct response. -7.48e+11. What is the difference between the Exports (in Local Currency Unit) in Finland in 2003 and the Exports (in Local Currency Unit) in Lithuania in 2004?
Provide a succinct answer. 4.78e+1. What is the difference between the Exports (in Local Currency Unit) of Germany in 2003 and the Exports (in Local Currency Unit) of Lithuania in 2004?
Offer a terse response. 7.15e+11. What is the difference between the Exports (in Local Currency Unit) of Bahrain in 2003 and the Exports (in Local Currency Unit) of Finland in 2005?
Provide a succinct answer. -6.32e+1. What is the difference between the Exports (in Local Currency Unit) of Bahrain in 2003 and the Exports (in Local Currency Unit) of Germany in 2005?
Offer a terse response. -8.65e+11. What is the difference between the Exports (in Local Currency Unit) in Bahrain in 2003 and the Exports (in Local Currency Unit) in Lithuania in 2005?
Provide a succinct answer. -8.32e+09. What is the difference between the Exports (in Local Currency Unit) of Finland in 2003 and the Exports (in Local Currency Unit) of Germany in 2005?
Provide a succinct answer. -8.12e+11. What is the difference between the Exports (in Local Currency Unit) of Finland in 2003 and the Exports (in Local Currency Unit) of Lithuania in 2005?
Offer a very short reply. 4.52e+1. What is the difference between the Exports (in Local Currency Unit) in Germany in 2003 and the Exports (in Local Currency Unit) in Lithuania in 2005?
Provide a succinct answer. 7.12e+11. What is the difference between the Exports (in Local Currency Unit) of Bahrain in 2004 and the Exports (in Local Currency Unit) of Finland in 2005?
Give a very brief answer. -6.23e+1. What is the difference between the Exports (in Local Currency Unit) of Bahrain in 2004 and the Exports (in Local Currency Unit) of Germany in 2005?
Offer a terse response. -8.64e+11. What is the difference between the Exports (in Local Currency Unit) of Bahrain in 2004 and the Exports (in Local Currency Unit) of Lithuania in 2005?
Provide a short and direct response. -7.44e+09. What is the difference between the Exports (in Local Currency Unit) of Finland in 2004 and the Exports (in Local Currency Unit) of Germany in 2005?
Make the answer very short. -8.07e+11. What is the difference between the Exports (in Local Currency Unit) of Finland in 2004 and the Exports (in Local Currency Unit) of Lithuania in 2005?
Offer a terse response. 4.98e+1. What is the difference between the Exports (in Local Currency Unit) in Germany in 2004 and the Exports (in Local Currency Unit) in Lithuania in 2005?
Your answer should be compact. 7.94e+11. What is the average Exports (in Local Currency Unit) of Bahrain per year?
Make the answer very short. 2.90e+09. What is the average Exports (in Local Currency Unit) of Finland per year?
Provide a short and direct response. 5.62e+1. What is the average Exports (in Local Currency Unit) of Germany per year?
Give a very brief answer. 6.94e+11. What is the average Exports (in Local Currency Unit) of Lithuania per year?
Your answer should be very brief. 6.94e+09. In the year 1998, what is the difference between the Exports (in Local Currency Unit) of Bahrain and Exports (in Local Currency Unit) of Finland?
Your answer should be very brief. -4.36e+1. In the year 1998, what is the difference between the Exports (in Local Currency Unit) of Bahrain and Exports (in Local Currency Unit) of Germany?
Offer a terse response. -5.32e+11. In the year 1998, what is the difference between the Exports (in Local Currency Unit) of Bahrain and Exports (in Local Currency Unit) of Lithuania?
Offer a terse response. -3.59e+09. In the year 1998, what is the difference between the Exports (in Local Currency Unit) of Finland and Exports (in Local Currency Unit) of Germany?
Keep it short and to the point. -4.89e+11. In the year 1998, what is the difference between the Exports (in Local Currency Unit) in Finland and Exports (in Local Currency Unit) in Lithuania?
Provide a succinct answer. 4.00e+1. In the year 1998, what is the difference between the Exports (in Local Currency Unit) of Germany and Exports (in Local Currency Unit) of Lithuania?
Keep it short and to the point. 5.29e+11. In the year 1999, what is the difference between the Exports (in Local Currency Unit) of Bahrain and Exports (in Local Currency Unit) of Finland?
Offer a very short reply. -4.58e+1. In the year 1999, what is the difference between the Exports (in Local Currency Unit) of Bahrain and Exports (in Local Currency Unit) of Germany?
Offer a terse response. -5.56e+11. In the year 1999, what is the difference between the Exports (in Local Currency Unit) of Bahrain and Exports (in Local Currency Unit) of Lithuania?
Your answer should be very brief. -2.16e+09. In the year 1999, what is the difference between the Exports (in Local Currency Unit) in Finland and Exports (in Local Currency Unit) in Germany?
Give a very brief answer. -5.11e+11. In the year 1999, what is the difference between the Exports (in Local Currency Unit) of Finland and Exports (in Local Currency Unit) of Lithuania?
Provide a succinct answer. 4.36e+1. In the year 1999, what is the difference between the Exports (in Local Currency Unit) in Germany and Exports (in Local Currency Unit) in Lithuania?
Provide a succinct answer. 5.54e+11. In the year 2000, what is the difference between the Exports (in Local Currency Unit) of Bahrain and Exports (in Local Currency Unit) of Finland?
Your answer should be very brief. -5.46e+1. In the year 2000, what is the difference between the Exports (in Local Currency Unit) in Bahrain and Exports (in Local Currency Unit) in Germany?
Make the answer very short. -6.50e+11. In the year 2000, what is the difference between the Exports (in Local Currency Unit) in Bahrain and Exports (in Local Currency Unit) in Lithuania?
Offer a terse response. -2.45e+09. In the year 2000, what is the difference between the Exports (in Local Currency Unit) of Finland and Exports (in Local Currency Unit) of Germany?
Give a very brief answer. -5.95e+11. In the year 2000, what is the difference between the Exports (in Local Currency Unit) of Finland and Exports (in Local Currency Unit) of Lithuania?
Make the answer very short. 5.22e+1. In the year 2000, what is the difference between the Exports (in Local Currency Unit) of Germany and Exports (in Local Currency Unit) of Lithuania?
Your answer should be compact. 6.47e+11. In the year 2001, what is the difference between the Exports (in Local Currency Unit) of Bahrain and Exports (in Local Currency Unit) of Finland?
Your answer should be compact. -5.49e+1. In the year 2001, what is the difference between the Exports (in Local Currency Unit) of Bahrain and Exports (in Local Currency Unit) of Germany?
Your response must be concise. -6.92e+11. In the year 2001, what is the difference between the Exports (in Local Currency Unit) of Bahrain and Exports (in Local Currency Unit) of Lithuania?
Provide a succinct answer. -3.77e+09. In the year 2001, what is the difference between the Exports (in Local Currency Unit) in Finland and Exports (in Local Currency Unit) in Germany?
Keep it short and to the point. -6.37e+11. In the year 2001, what is the difference between the Exports (in Local Currency Unit) of Finland and Exports (in Local Currency Unit) of Lithuania?
Ensure brevity in your answer.  5.11e+1. In the year 2001, what is the difference between the Exports (in Local Currency Unit) of Germany and Exports (in Local Currency Unit) of Lithuania?
Give a very brief answer. 6.88e+11. In the year 2002, what is the difference between the Exports (in Local Currency Unit) of Bahrain and Exports (in Local Currency Unit) of Finland?
Keep it short and to the point. -5.53e+1. In the year 2002, what is the difference between the Exports (in Local Currency Unit) of Bahrain and Exports (in Local Currency Unit) of Germany?
Ensure brevity in your answer.  -7.17e+11. In the year 2002, what is the difference between the Exports (in Local Currency Unit) of Bahrain and Exports (in Local Currency Unit) of Lithuania?
Your answer should be compact. -4.58e+09. In the year 2002, what is the difference between the Exports (in Local Currency Unit) of Finland and Exports (in Local Currency Unit) of Germany?
Your response must be concise. -6.62e+11. In the year 2002, what is the difference between the Exports (in Local Currency Unit) in Finland and Exports (in Local Currency Unit) in Lithuania?
Offer a terse response. 5.08e+1. In the year 2002, what is the difference between the Exports (in Local Currency Unit) in Germany and Exports (in Local Currency Unit) in Lithuania?
Make the answer very short. 7.12e+11. In the year 2003, what is the difference between the Exports (in Local Currency Unit) in Bahrain and Exports (in Local Currency Unit) in Finland?
Offer a terse response. -5.35e+1. In the year 2003, what is the difference between the Exports (in Local Currency Unit) of Bahrain and Exports (in Local Currency Unit) of Germany?
Offer a terse response. -7.21e+11. In the year 2003, what is the difference between the Exports (in Local Currency Unit) of Bahrain and Exports (in Local Currency Unit) of Lithuania?
Make the answer very short. -4.69e+09. In the year 2003, what is the difference between the Exports (in Local Currency Unit) of Finland and Exports (in Local Currency Unit) of Germany?
Your response must be concise. -6.67e+11. In the year 2003, what is the difference between the Exports (in Local Currency Unit) in Finland and Exports (in Local Currency Unit) in Lithuania?
Provide a short and direct response. 4.88e+1. In the year 2003, what is the difference between the Exports (in Local Currency Unit) of Germany and Exports (in Local Currency Unit) of Lithuania?
Offer a terse response. 7.16e+11. In the year 2004, what is the difference between the Exports (in Local Currency Unit) of Bahrain and Exports (in Local Currency Unit) of Finland?
Give a very brief answer. -5.73e+1. In the year 2004, what is the difference between the Exports (in Local Currency Unit) in Bahrain and Exports (in Local Currency Unit) in Germany?
Offer a terse response. -8.01e+11. In the year 2004, what is the difference between the Exports (in Local Currency Unit) in Bahrain and Exports (in Local Currency Unit) in Lithuania?
Your answer should be very brief. -4.76e+09. In the year 2004, what is the difference between the Exports (in Local Currency Unit) of Finland and Exports (in Local Currency Unit) of Germany?
Keep it short and to the point. -7.44e+11. In the year 2004, what is the difference between the Exports (in Local Currency Unit) of Finland and Exports (in Local Currency Unit) of Lithuania?
Provide a short and direct response. 5.25e+1. In the year 2004, what is the difference between the Exports (in Local Currency Unit) of Germany and Exports (in Local Currency Unit) of Lithuania?
Your response must be concise. 7.96e+11. In the year 2005, what is the difference between the Exports (in Local Currency Unit) of Bahrain and Exports (in Local Currency Unit) of Finland?
Your response must be concise. -6.11e+1. In the year 2005, what is the difference between the Exports (in Local Currency Unit) of Bahrain and Exports (in Local Currency Unit) of Germany?
Provide a succinct answer. -8.63e+11. In the year 2005, what is the difference between the Exports (in Local Currency Unit) in Bahrain and Exports (in Local Currency Unit) in Lithuania?
Offer a very short reply. -6.29e+09. In the year 2005, what is the difference between the Exports (in Local Currency Unit) in Finland and Exports (in Local Currency Unit) in Germany?
Your answer should be compact. -8.02e+11. In the year 2005, what is the difference between the Exports (in Local Currency Unit) in Finland and Exports (in Local Currency Unit) in Lithuania?
Provide a short and direct response. 5.49e+1. In the year 2005, what is the difference between the Exports (in Local Currency Unit) in Germany and Exports (in Local Currency Unit) in Lithuania?
Your response must be concise. 8.57e+11. What is the ratio of the Exports (in Local Currency Unit) of Bahrain in 1998 to that in 1999?
Provide a succinct answer. 0.77. What is the ratio of the Exports (in Local Currency Unit) of Finland in 1998 to that in 1999?
Give a very brief answer. 0.95. What is the ratio of the Exports (in Local Currency Unit) in Germany in 1998 to that in 1999?
Ensure brevity in your answer.  0.96. What is the ratio of the Exports (in Local Currency Unit) in Lithuania in 1998 to that in 1999?
Offer a very short reply. 1.24. What is the ratio of the Exports (in Local Currency Unit) of Bahrain in 1998 to that in 2000?
Offer a terse response. 0.56. What is the ratio of the Exports (in Local Currency Unit) of Finland in 1998 to that in 2000?
Offer a very short reply. 0.79. What is the ratio of the Exports (in Local Currency Unit) of Germany in 1998 to that in 2000?
Your answer should be compact. 0.82. What is the ratio of the Exports (in Local Currency Unit) of Lithuania in 1998 to that in 2000?
Your response must be concise. 0.99. What is the ratio of the Exports (in Local Currency Unit) of Bahrain in 1998 to that in 2001?
Make the answer very short. 0.6. What is the ratio of the Exports (in Local Currency Unit) in Finland in 1998 to that in 2001?
Your response must be concise. 0.79. What is the ratio of the Exports (in Local Currency Unit) in Germany in 1998 to that in 2001?
Your response must be concise. 0.77. What is the ratio of the Exports (in Local Currency Unit) in Lithuania in 1998 to that in 2001?
Keep it short and to the point. 0.81. What is the ratio of the Exports (in Local Currency Unit) in Bahrain in 1998 to that in 2002?
Keep it short and to the point. 0.57. What is the ratio of the Exports (in Local Currency Unit) in Finland in 1998 to that in 2002?
Your answer should be compact. 0.78. What is the ratio of the Exports (in Local Currency Unit) of Germany in 1998 to that in 2002?
Provide a succinct answer. 0.74. What is the ratio of the Exports (in Local Currency Unit) in Lithuania in 1998 to that in 2002?
Your answer should be very brief. 0.71. What is the ratio of the Exports (in Local Currency Unit) in Bahrain in 1998 to that in 2003?
Your response must be concise. 0.5. What is the ratio of the Exports (in Local Currency Unit) of Finland in 1998 to that in 2003?
Offer a very short reply. 0.8. What is the ratio of the Exports (in Local Currency Unit) of Germany in 1998 to that in 2003?
Provide a short and direct response. 0.74. What is the ratio of the Exports (in Local Currency Unit) of Lithuania in 1998 to that in 2003?
Your answer should be compact. 0.66. What is the ratio of the Exports (in Local Currency Unit) of Bahrain in 1998 to that in 2004?
Make the answer very short. 0.39. What is the ratio of the Exports (in Local Currency Unit) in Finland in 1998 to that in 2004?
Offer a terse response. 0.74. What is the ratio of the Exports (in Local Currency Unit) of Germany in 1998 to that in 2004?
Your answer should be very brief. 0.66. What is the ratio of the Exports (in Local Currency Unit) in Lithuania in 1998 to that in 2004?
Make the answer very short. 0.59. What is the ratio of the Exports (in Local Currency Unit) in Bahrain in 1998 to that in 2005?
Your response must be concise. 0.3. What is the ratio of the Exports (in Local Currency Unit) of Finland in 1998 to that in 2005?
Your response must be concise. 0.68. What is the ratio of the Exports (in Local Currency Unit) in Germany in 1998 to that in 2005?
Your answer should be very brief. 0.61. What is the ratio of the Exports (in Local Currency Unit) in Lithuania in 1998 to that in 2005?
Provide a succinct answer. 0.45. What is the ratio of the Exports (in Local Currency Unit) in Bahrain in 1999 to that in 2000?
Ensure brevity in your answer.  0.73. What is the ratio of the Exports (in Local Currency Unit) of Finland in 1999 to that in 2000?
Offer a terse response. 0.83. What is the ratio of the Exports (in Local Currency Unit) of Germany in 1999 to that in 2000?
Make the answer very short. 0.86. What is the ratio of the Exports (in Local Currency Unit) in Lithuania in 1999 to that in 2000?
Your answer should be compact. 0.8. What is the ratio of the Exports (in Local Currency Unit) of Bahrain in 1999 to that in 2001?
Make the answer very short. 0.79. What is the ratio of the Exports (in Local Currency Unit) of Finland in 1999 to that in 2001?
Offer a very short reply. 0.83. What is the ratio of the Exports (in Local Currency Unit) in Germany in 1999 to that in 2001?
Offer a terse response. 0.8. What is the ratio of the Exports (in Local Currency Unit) in Lithuania in 1999 to that in 2001?
Your answer should be compact. 0.66. What is the ratio of the Exports (in Local Currency Unit) of Bahrain in 1999 to that in 2002?
Provide a short and direct response. 0.75. What is the ratio of the Exports (in Local Currency Unit) in Finland in 1999 to that in 2002?
Keep it short and to the point. 0.82. What is the ratio of the Exports (in Local Currency Unit) of Germany in 1999 to that in 2002?
Offer a terse response. 0.78. What is the ratio of the Exports (in Local Currency Unit) in Lithuania in 1999 to that in 2002?
Offer a very short reply. 0.57. What is the ratio of the Exports (in Local Currency Unit) in Bahrain in 1999 to that in 2003?
Your answer should be very brief. 0.65. What is the ratio of the Exports (in Local Currency Unit) in Finland in 1999 to that in 2003?
Your answer should be very brief. 0.84. What is the ratio of the Exports (in Local Currency Unit) in Germany in 1999 to that in 2003?
Give a very brief answer. 0.77. What is the ratio of the Exports (in Local Currency Unit) of Lithuania in 1999 to that in 2003?
Your response must be concise. 0.54. What is the ratio of the Exports (in Local Currency Unit) of Bahrain in 1999 to that in 2004?
Make the answer very short. 0.51. What is the ratio of the Exports (in Local Currency Unit) of Finland in 1999 to that in 2004?
Your response must be concise. 0.78. What is the ratio of the Exports (in Local Currency Unit) of Germany in 1999 to that in 2004?
Offer a terse response. 0.69. What is the ratio of the Exports (in Local Currency Unit) of Lithuania in 1999 to that in 2004?
Offer a very short reply. 0.48. What is the ratio of the Exports (in Local Currency Unit) of Bahrain in 1999 to that in 2005?
Your answer should be compact. 0.39. What is the ratio of the Exports (in Local Currency Unit) of Finland in 1999 to that in 2005?
Offer a terse response. 0.72. What is the ratio of the Exports (in Local Currency Unit) of Germany in 1999 to that in 2005?
Give a very brief answer. 0.64. What is the ratio of the Exports (in Local Currency Unit) of Lithuania in 1999 to that in 2005?
Ensure brevity in your answer.  0.36. What is the ratio of the Exports (in Local Currency Unit) of Bahrain in 2000 to that in 2001?
Provide a succinct answer. 1.09. What is the ratio of the Exports (in Local Currency Unit) of Finland in 2000 to that in 2001?
Your answer should be compact. 1. What is the ratio of the Exports (in Local Currency Unit) of Germany in 2000 to that in 2001?
Give a very brief answer. 0.94. What is the ratio of the Exports (in Local Currency Unit) in Lithuania in 2000 to that in 2001?
Your answer should be very brief. 0.82. What is the ratio of the Exports (in Local Currency Unit) in Bahrain in 2000 to that in 2002?
Offer a terse response. 1.03. What is the ratio of the Exports (in Local Currency Unit) in Finland in 2000 to that in 2002?
Ensure brevity in your answer.  0.99. What is the ratio of the Exports (in Local Currency Unit) of Germany in 2000 to that in 2002?
Keep it short and to the point. 0.91. What is the ratio of the Exports (in Local Currency Unit) of Lithuania in 2000 to that in 2002?
Your response must be concise. 0.72. What is the ratio of the Exports (in Local Currency Unit) of Bahrain in 2000 to that in 2003?
Offer a very short reply. 0.9. What is the ratio of the Exports (in Local Currency Unit) of Finland in 2000 to that in 2003?
Your answer should be compact. 1.02. What is the ratio of the Exports (in Local Currency Unit) of Germany in 2000 to that in 2003?
Provide a succinct answer. 0.9. What is the ratio of the Exports (in Local Currency Unit) of Lithuania in 2000 to that in 2003?
Provide a short and direct response. 0.67. What is the ratio of the Exports (in Local Currency Unit) of Bahrain in 2000 to that in 2004?
Your answer should be compact. 0.69. What is the ratio of the Exports (in Local Currency Unit) of Finland in 2000 to that in 2004?
Make the answer very short. 0.94. What is the ratio of the Exports (in Local Currency Unit) of Germany in 2000 to that in 2004?
Keep it short and to the point. 0.81. What is the ratio of the Exports (in Local Currency Unit) of Lithuania in 2000 to that in 2004?
Your answer should be compact. 0.6. What is the ratio of the Exports (in Local Currency Unit) of Bahrain in 2000 to that in 2005?
Offer a terse response. 0.54. What is the ratio of the Exports (in Local Currency Unit) in Finland in 2000 to that in 2005?
Offer a terse response. 0.87. What is the ratio of the Exports (in Local Currency Unit) in Germany in 2000 to that in 2005?
Keep it short and to the point. 0.75. What is the ratio of the Exports (in Local Currency Unit) of Lithuania in 2000 to that in 2005?
Make the answer very short. 0.46. What is the ratio of the Exports (in Local Currency Unit) in Bahrain in 2001 to that in 2002?
Ensure brevity in your answer.  0.95. What is the ratio of the Exports (in Local Currency Unit) in Germany in 2001 to that in 2002?
Provide a short and direct response. 0.97. What is the ratio of the Exports (in Local Currency Unit) in Lithuania in 2001 to that in 2002?
Your response must be concise. 0.87. What is the ratio of the Exports (in Local Currency Unit) in Bahrain in 2001 to that in 2003?
Your answer should be very brief. 0.83. What is the ratio of the Exports (in Local Currency Unit) of Finland in 2001 to that in 2003?
Provide a succinct answer. 1.02. What is the ratio of the Exports (in Local Currency Unit) of Germany in 2001 to that in 2003?
Offer a terse response. 0.96. What is the ratio of the Exports (in Local Currency Unit) in Lithuania in 2001 to that in 2003?
Make the answer very short. 0.81. What is the ratio of the Exports (in Local Currency Unit) of Bahrain in 2001 to that in 2004?
Provide a succinct answer. 0.64. What is the ratio of the Exports (in Local Currency Unit) of Finland in 2001 to that in 2004?
Ensure brevity in your answer.  0.94. What is the ratio of the Exports (in Local Currency Unit) of Germany in 2001 to that in 2004?
Provide a short and direct response. 0.86. What is the ratio of the Exports (in Local Currency Unit) in Lithuania in 2001 to that in 2004?
Give a very brief answer. 0.72. What is the ratio of the Exports (in Local Currency Unit) in Bahrain in 2001 to that in 2005?
Make the answer very short. 0.49. What is the ratio of the Exports (in Local Currency Unit) of Finland in 2001 to that in 2005?
Your response must be concise. 0.87. What is the ratio of the Exports (in Local Currency Unit) in Germany in 2001 to that in 2005?
Offer a very short reply. 0.8. What is the ratio of the Exports (in Local Currency Unit) in Lithuania in 2001 to that in 2005?
Provide a short and direct response. 0.55. What is the ratio of the Exports (in Local Currency Unit) of Bahrain in 2002 to that in 2003?
Provide a short and direct response. 0.87. What is the ratio of the Exports (in Local Currency Unit) of Finland in 2002 to that in 2003?
Ensure brevity in your answer.  1.03. What is the ratio of the Exports (in Local Currency Unit) of Germany in 2002 to that in 2003?
Offer a terse response. 0.99. What is the ratio of the Exports (in Local Currency Unit) of Lithuania in 2002 to that in 2003?
Your answer should be very brief. 0.94. What is the ratio of the Exports (in Local Currency Unit) of Bahrain in 2002 to that in 2004?
Offer a very short reply. 0.67. What is the ratio of the Exports (in Local Currency Unit) in Finland in 2002 to that in 2004?
Ensure brevity in your answer.  0.95. What is the ratio of the Exports (in Local Currency Unit) of Germany in 2002 to that in 2004?
Offer a terse response. 0.89. What is the ratio of the Exports (in Local Currency Unit) of Lithuania in 2002 to that in 2004?
Keep it short and to the point. 0.83. What is the ratio of the Exports (in Local Currency Unit) in Bahrain in 2002 to that in 2005?
Offer a terse response. 0.52. What is the ratio of the Exports (in Local Currency Unit) in Finland in 2002 to that in 2005?
Offer a very short reply. 0.88. What is the ratio of the Exports (in Local Currency Unit) of Germany in 2002 to that in 2005?
Your answer should be very brief. 0.83. What is the ratio of the Exports (in Local Currency Unit) in Lithuania in 2002 to that in 2005?
Offer a terse response. 0.64. What is the ratio of the Exports (in Local Currency Unit) of Bahrain in 2003 to that in 2004?
Keep it short and to the point. 0.77. What is the ratio of the Exports (in Local Currency Unit) in Finland in 2003 to that in 2004?
Your answer should be very brief. 0.92. What is the ratio of the Exports (in Local Currency Unit) in Germany in 2003 to that in 2004?
Provide a succinct answer. 0.9. What is the ratio of the Exports (in Local Currency Unit) of Lithuania in 2003 to that in 2004?
Your answer should be compact. 0.89. What is the ratio of the Exports (in Local Currency Unit) in Bahrain in 2003 to that in 2005?
Provide a short and direct response. 0.6. What is the ratio of the Exports (in Local Currency Unit) in Finland in 2003 to that in 2005?
Your answer should be compact. 0.85. What is the ratio of the Exports (in Local Currency Unit) of Lithuania in 2003 to that in 2005?
Your response must be concise. 0.68. What is the ratio of the Exports (in Local Currency Unit) in Bahrain in 2004 to that in 2005?
Provide a short and direct response. 0.77. What is the ratio of the Exports (in Local Currency Unit) of Finland in 2004 to that in 2005?
Give a very brief answer. 0.92. What is the ratio of the Exports (in Local Currency Unit) in Germany in 2004 to that in 2005?
Ensure brevity in your answer.  0.93. What is the ratio of the Exports (in Local Currency Unit) in Lithuania in 2004 to that in 2005?
Give a very brief answer. 0.76. What is the difference between the highest and the second highest Exports (in Local Currency Unit) of Bahrain?
Make the answer very short. 1.15e+09. What is the difference between the highest and the second highest Exports (in Local Currency Unit) of Finland?
Keep it short and to the point. 5.02e+09. What is the difference between the highest and the second highest Exports (in Local Currency Unit) of Germany?
Keep it short and to the point. 6.35e+1. What is the difference between the highest and the second highest Exports (in Local Currency Unit) of Lithuania?
Keep it short and to the point. 2.68e+09. What is the difference between the highest and the lowest Exports (in Local Currency Unit) in Bahrain?
Your answer should be compact. 3.54e+09. What is the difference between the highest and the lowest Exports (in Local Currency Unit) of Finland?
Provide a succinct answer. 2.11e+1. What is the difference between the highest and the lowest Exports (in Local Currency Unit) in Germany?
Your answer should be very brief. 3.34e+11. What is the difference between the highest and the lowest Exports (in Local Currency Unit) of Lithuania?
Offer a very short reply. 7.20e+09. 